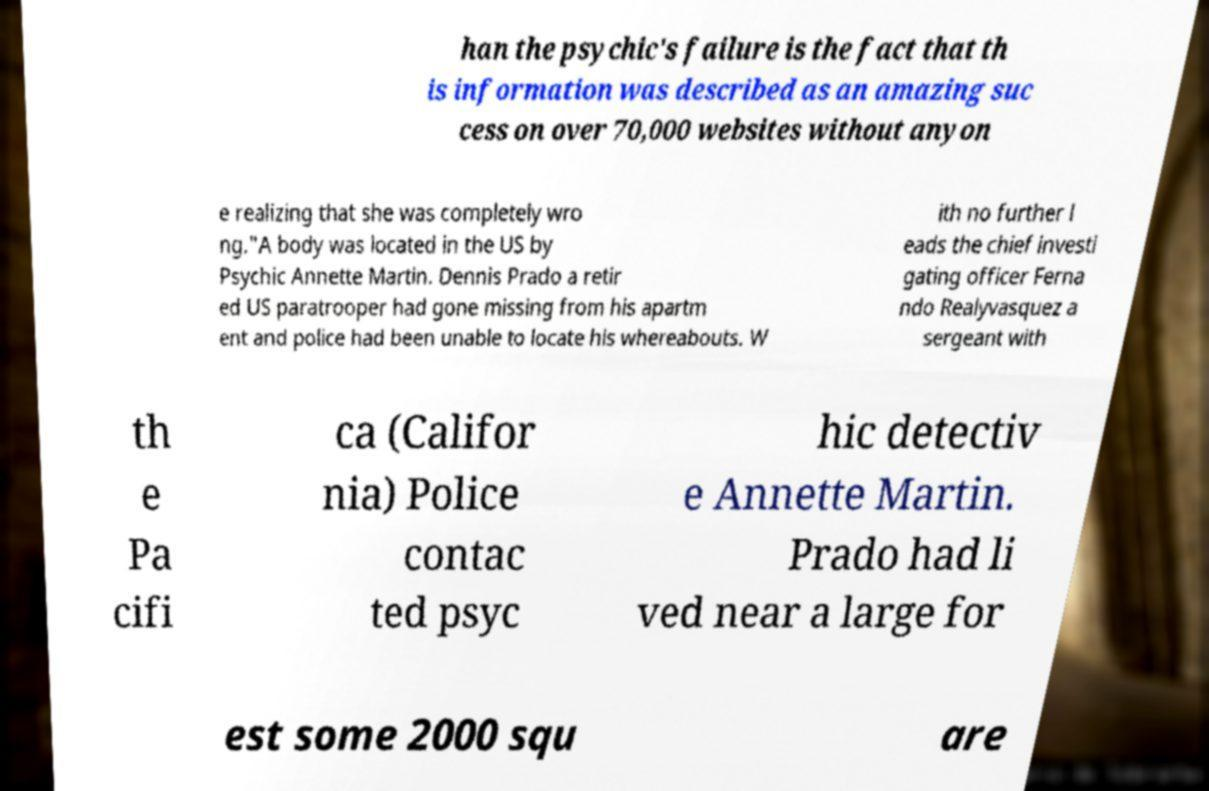For documentation purposes, I need the text within this image transcribed. Could you provide that? han the psychic's failure is the fact that th is information was described as an amazing suc cess on over 70,000 websites without anyon e realizing that she was completely wro ng."A body was located in the US by Psychic Annette Martin. Dennis Prado a retir ed US paratrooper had gone missing from his apartm ent and police had been unable to locate his whereabouts. W ith no further l eads the chief investi gating officer Ferna ndo Realyvasquez a sergeant with th e Pa cifi ca (Califor nia) Police contac ted psyc hic detectiv e Annette Martin. Prado had li ved near a large for est some 2000 squ are 